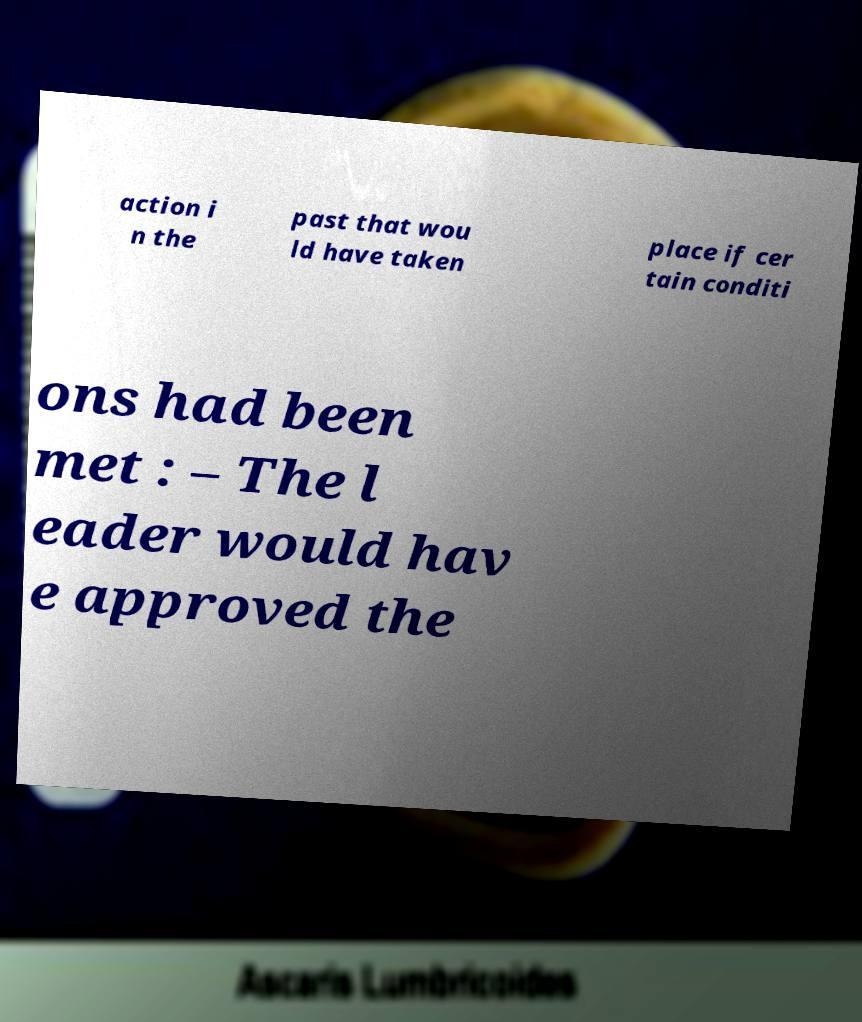Can you accurately transcribe the text from the provided image for me? action i n the past that wou ld have taken place if cer tain conditi ons had been met : – The l eader would hav e approved the 